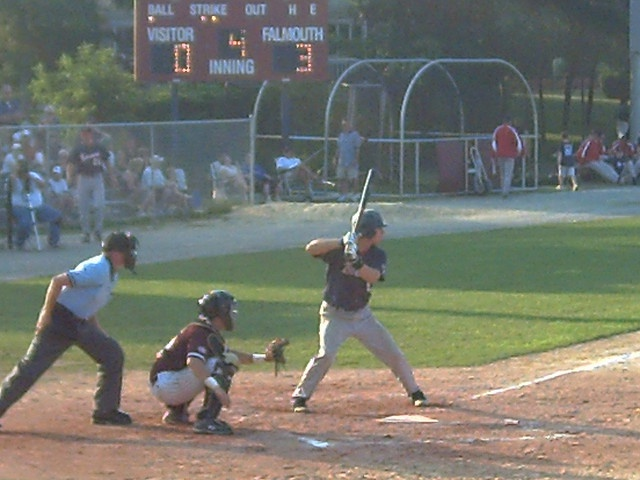Describe the objects in this image and their specific colors. I can see people in gray and black tones, people in gray tones, people in gray and darkgray tones, people in gray tones, and people in gray and blue tones in this image. 